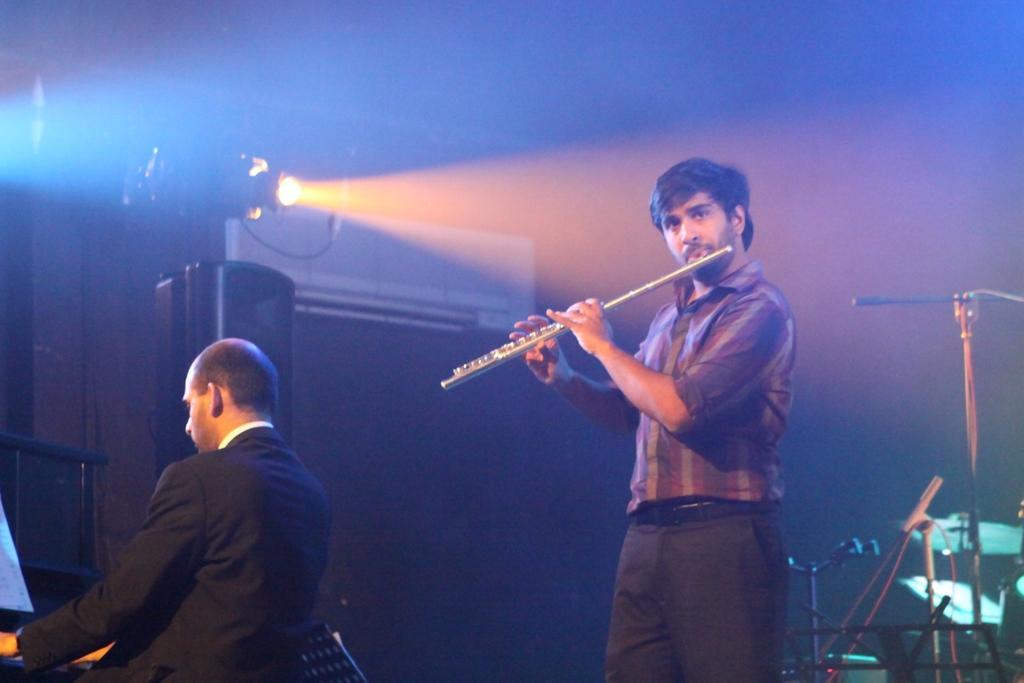Describe this image in one or two sentences. In this image there is one person who is standing, and he is playing a flute and on the left side there is one person playing some musical instrument it seems. And on the right side there are some drums and mike, in the background there is light and objects and black background. 